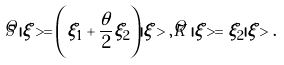Convert formula to latex. <formula><loc_0><loc_0><loc_500><loc_500>\hat { S } \, | \xi > = \left ( \xi _ { 1 } + \frac { \theta } { 2 } \xi _ { 2 } \right ) | \xi > , \hat { K } \, | \xi > = \xi _ { 2 } | \xi > .</formula> 